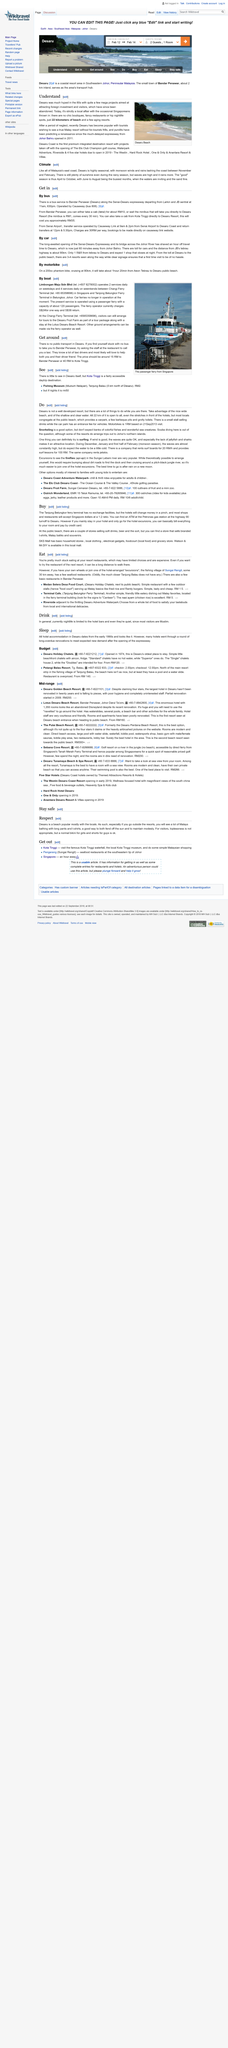Point out several critical features in this image. The Tanjung Belungkor Ferry Terminal is the name of the terminal located nearest to Terminal Cafe, and it is located in the area. The waterpark adjacent to Riverside is named Desaru Adventure Waterpark. Desaru has no public transport available. Snorkeling is a suitable activity, but one should not anticipate observing vast populations of vibrant fishes and exotic sea life. The Johor Bahru expressway opened in 2011. 